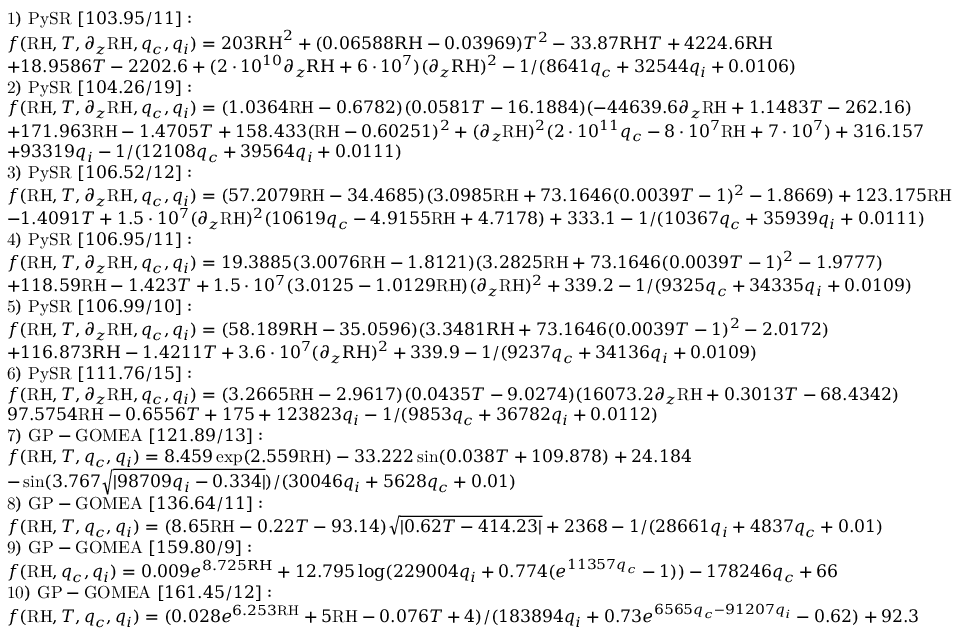<formula> <loc_0><loc_0><loc_500><loc_500>\begin{array} { r l } & { 1 ) P y S R [ 1 0 3 . 9 5 / 1 1 ] \colon } \\ & { f ( R H , T , \partial _ { z } R H , q _ { c } , q _ { i } ) = 2 0 3 R H ^ { 2 } + ( 0 . 0 6 5 8 8 R H - 0 . 0 3 9 6 9 ) T ^ { 2 } - 3 3 . 8 7 R H T + 4 2 2 4 . 6 R H } \\ & { + 1 8 . 9 5 8 6 T - 2 2 0 2 . 6 + ( 2 \cdot 1 0 ^ { 1 0 } \partial _ { z } R H + 6 \cdot 1 0 ^ { 7 } ) ( \partial _ { z } R H ) ^ { 2 } - 1 / ( 8 6 4 1 q _ { c } + 3 2 5 4 4 q _ { i } + 0 . 0 1 0 6 ) } \\ & { 2 ) P y S R [ 1 0 4 . 2 6 / 1 9 ] \colon } \\ & { f ( R H , T , \partial _ { z } R H , q _ { c } , q _ { i } ) = ( 1 . 0 3 6 4 R H - 0 . 6 7 8 2 ) ( 0 . 0 5 8 1 T - 1 6 . 1 8 8 4 ) ( - 4 4 6 3 9 . 6 \partial _ { z } R H + 1 . 1 4 8 3 T - 2 6 2 . 1 6 ) } \\ & { + 1 7 1 . 9 6 3 R H - 1 . 4 7 0 5 T + 1 5 8 . 4 3 3 ( R H - 0 . 6 0 2 5 1 ) ^ { 2 } + ( \partial _ { z } R H ) ^ { 2 } ( 2 \cdot 1 0 ^ { 1 1 } q _ { c } - 8 \cdot 1 0 ^ { 7 } R H + 7 \cdot 1 0 ^ { 7 } ) + 3 1 6 . 1 5 7 } \\ & { + 9 3 3 1 9 q _ { i } - 1 / ( 1 2 1 0 8 q _ { c } + 3 9 5 6 4 q _ { i } + 0 . 0 1 1 1 ) } \\ & { 3 ) P y S R [ 1 0 6 . 5 2 / 1 2 ] \colon } \\ & { f ( R H , T , \partial _ { z } R H , q _ { c } , q _ { i } ) = ( 5 7 . 2 0 7 9 R H - 3 4 . 4 6 8 5 ) ( 3 . 0 9 8 5 R H + 7 3 . 1 6 4 6 ( 0 . 0 0 3 9 T - 1 ) ^ { 2 } - 1 . 8 6 6 9 ) + 1 2 3 . 1 7 5 R H } \\ & { - 1 . 4 0 9 1 T + 1 . 5 \cdot 1 0 ^ { 7 } ( \partial _ { z } R H ) ^ { 2 } ( 1 0 6 1 9 q _ { c } - 4 . 9 1 5 5 R H + 4 . 7 1 7 8 ) + 3 3 3 . 1 - 1 / ( 1 0 3 6 7 q _ { c } + 3 5 9 3 9 q _ { i } + 0 . 0 1 1 1 ) } \\ & { 4 ) P y S R [ 1 0 6 . 9 5 / 1 1 ] \colon } \\ & { f ( R H , T , \partial _ { z } R H , q _ { c } , q _ { i } ) = 1 9 . 3 8 8 5 ( 3 . 0 0 7 6 R H - 1 . 8 1 2 1 ) ( 3 . 2 8 2 5 R H + 7 3 . 1 6 4 6 ( 0 . 0 0 3 9 T - 1 ) ^ { 2 } - 1 . 9 7 7 7 ) } \\ & { + 1 1 8 . 5 9 R H - 1 . 4 2 3 T + 1 . 5 \cdot 1 0 ^ { 7 } ( 3 . 0 1 2 5 - 1 . 0 1 2 9 R H ) ( \partial _ { z } R H ) ^ { 2 } + 3 3 9 . 2 - 1 / ( 9 3 2 5 q _ { c } + 3 4 3 3 5 q _ { i } + 0 . 0 1 0 9 ) } \\ & { 5 ) P y S R [ 1 0 6 . 9 9 / 1 0 ] \colon } \\ & { f ( R H , T , \partial _ { z } R H , q _ { c } , q _ { i } ) = ( 5 8 . 1 8 9 R H - 3 5 . 0 5 9 6 ) ( 3 . 3 4 8 1 R H + 7 3 . 1 6 4 6 ( 0 . 0 0 3 9 T - 1 ) ^ { 2 } - 2 . 0 1 7 2 ) } \\ & { + 1 1 6 . 8 7 3 R H - 1 . 4 2 1 1 T + 3 . 6 \cdot 1 0 ^ { 7 } ( \partial _ { z } R H ) ^ { 2 } + 3 3 9 . 9 - 1 / ( 9 2 3 7 q _ { c } + 3 4 1 3 6 q _ { i } + 0 . 0 1 0 9 ) } \\ & { 6 ) P y S R [ 1 1 1 . 7 6 / 1 5 ] \colon } \\ & { f ( R H , T , \partial _ { z } R H , q _ { c } , q _ { i } ) = ( 3 . 2 6 6 5 R H - 2 . 9 6 1 7 ) ( 0 . 0 4 3 5 T - 9 . 0 2 7 4 ) ( 1 6 0 7 3 . 2 \partial _ { z } R H + 0 . 3 0 1 3 T - 6 8 . 4 3 4 2 ) } \\ & { 9 7 . 5 7 5 4 R H - 0 . 6 5 5 6 T + 1 7 5 + 1 2 3 8 2 3 q _ { i } - 1 / ( 9 8 5 3 q _ { c } + 3 6 7 8 2 q _ { i } + 0 . 0 1 1 2 ) } \\ & { 7 ) G P - G O M E A [ 1 2 1 . 8 9 / 1 3 ] \colon } \\ & { f ( \mathrm { R H } , T , q _ { c } , q _ { i } ) = 8 . 4 5 9 \exp ( 2 . 5 5 9 R H ) - 3 3 . 2 2 2 \sin ( 0 . 0 3 8 T + 1 0 9 . 8 7 8 ) + 2 4 . 1 8 4 } \\ & { - \sin ( 3 . 7 6 7 \sqrt { | 9 8 7 0 9 q _ { i } - 0 . 3 3 4 | } ) / ( 3 0 0 4 6 q _ { i } + 5 6 2 8 q _ { c } + 0 . 0 1 ) } \\ & { 8 ) G P - G O M E A [ 1 3 6 . 6 4 / 1 1 ] \colon } \\ & { f ( \mathrm { R H } , T , q _ { c } , q _ { i } ) = ( 8 . 6 5 R H - 0 . 2 2 T - 9 3 . 1 4 ) \sqrt { | 0 . 6 2 T - 4 1 4 . 2 3 | } + 2 3 6 8 - 1 / ( 2 8 6 6 1 q _ { i } + 4 8 3 7 q _ { c } + 0 . 0 1 ) } \\ & { 9 ) G P - G O M E A [ 1 5 9 . 8 0 / 9 ] \colon } \\ & { f ( \mathrm { R H } , q _ { c } , q _ { i } ) = 0 . 0 0 9 e ^ { 8 . 7 2 5 R H } + 1 2 . 7 9 5 \log ( 2 2 9 0 0 4 q _ { i } + 0 . 7 7 4 ( e ^ { 1 1 3 5 7 q _ { c } } - 1 ) ) - 1 7 8 2 4 6 q _ { c } + 6 6 } \\ & { 1 0 ) G P - G O M E A [ 1 6 1 . 4 5 / 1 2 ] \colon } \\ & { f ( \mathrm { R H } , T , q _ { c } , q _ { i } ) = ( 0 . 0 2 8 e ^ { 6 . 2 5 3 R H } + 5 R H - 0 . 0 7 6 T + 4 ) / ( 1 8 3 8 9 4 q _ { i } + 0 . 7 3 e ^ { 6 5 6 5 q _ { c } - 9 1 2 0 7 q _ { i } } - 0 . 6 2 ) + 9 2 . 3 } \end{array}</formula> 